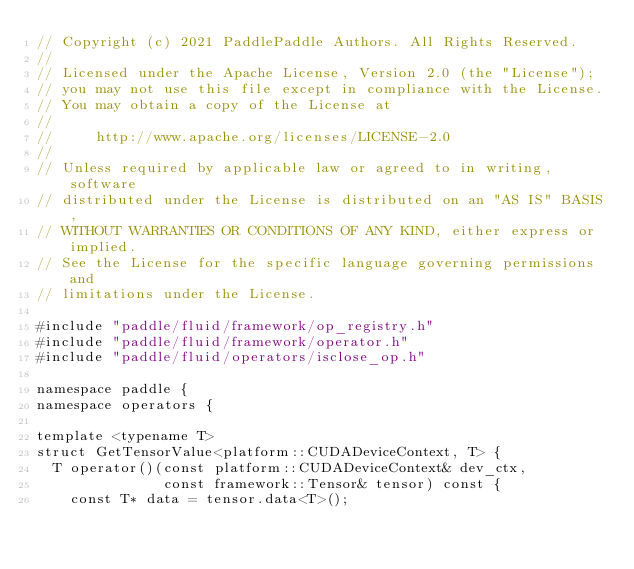Convert code to text. <code><loc_0><loc_0><loc_500><loc_500><_Cuda_>// Copyright (c) 2021 PaddlePaddle Authors. All Rights Reserved.
//
// Licensed under the Apache License, Version 2.0 (the "License");
// you may not use this file except in compliance with the License.
// You may obtain a copy of the License at
//
//     http://www.apache.org/licenses/LICENSE-2.0
//
// Unless required by applicable law or agreed to in writing, software
// distributed under the License is distributed on an "AS IS" BASIS,
// WITHOUT WARRANTIES OR CONDITIONS OF ANY KIND, either express or implied.
// See the License for the specific language governing permissions and
// limitations under the License.

#include "paddle/fluid/framework/op_registry.h"
#include "paddle/fluid/framework/operator.h"
#include "paddle/fluid/operators/isclose_op.h"

namespace paddle {
namespace operators {

template <typename T>
struct GetTensorValue<platform::CUDADeviceContext, T> {
  T operator()(const platform::CUDADeviceContext& dev_ctx,
               const framework::Tensor& tensor) const {
    const T* data = tensor.data<T>();</code> 